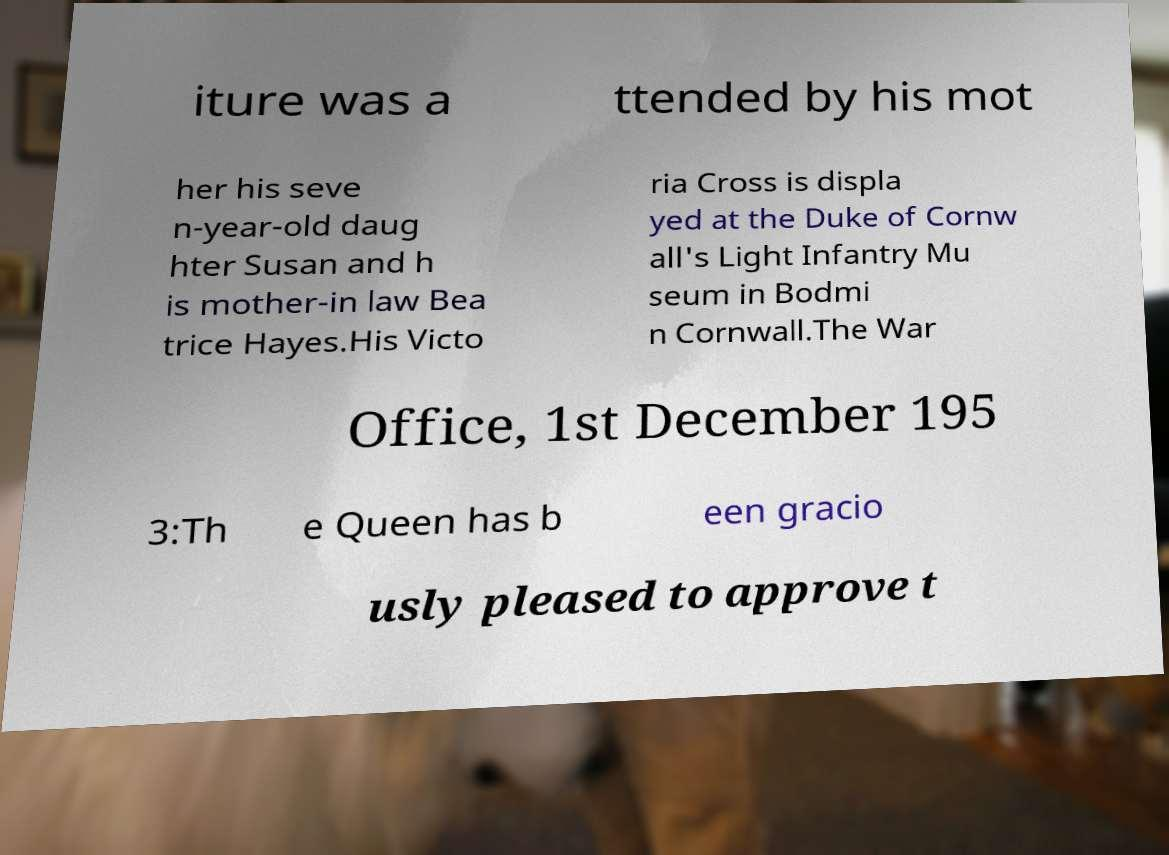Please identify and transcribe the text found in this image. iture was a ttended by his mot her his seve n-year-old daug hter Susan and h is mother-in law Bea trice Hayes.His Victo ria Cross is displa yed at the Duke of Cornw all's Light Infantry Mu seum in Bodmi n Cornwall.The War Office, 1st December 195 3:Th e Queen has b een gracio usly pleased to approve t 